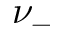Convert formula to latex. <formula><loc_0><loc_0><loc_500><loc_500>\nu _ { - }</formula> 